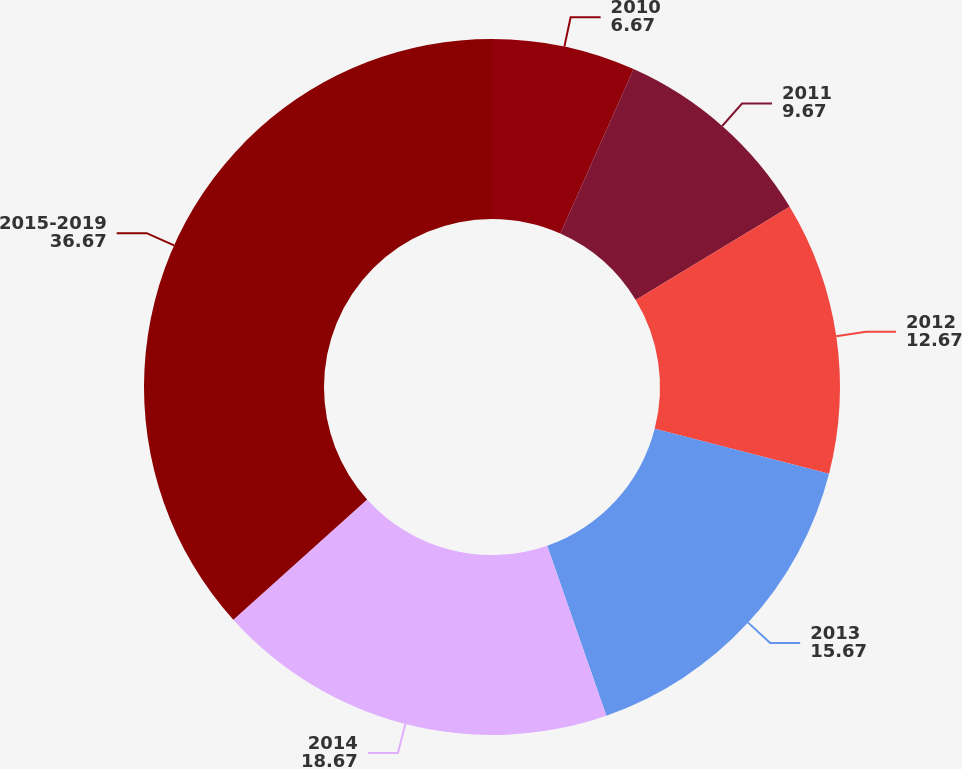Convert chart to OTSL. <chart><loc_0><loc_0><loc_500><loc_500><pie_chart><fcel>2010<fcel>2011<fcel>2012<fcel>2013<fcel>2014<fcel>2015-2019<nl><fcel>6.67%<fcel>9.67%<fcel>12.67%<fcel>15.67%<fcel>18.67%<fcel>36.67%<nl></chart> 